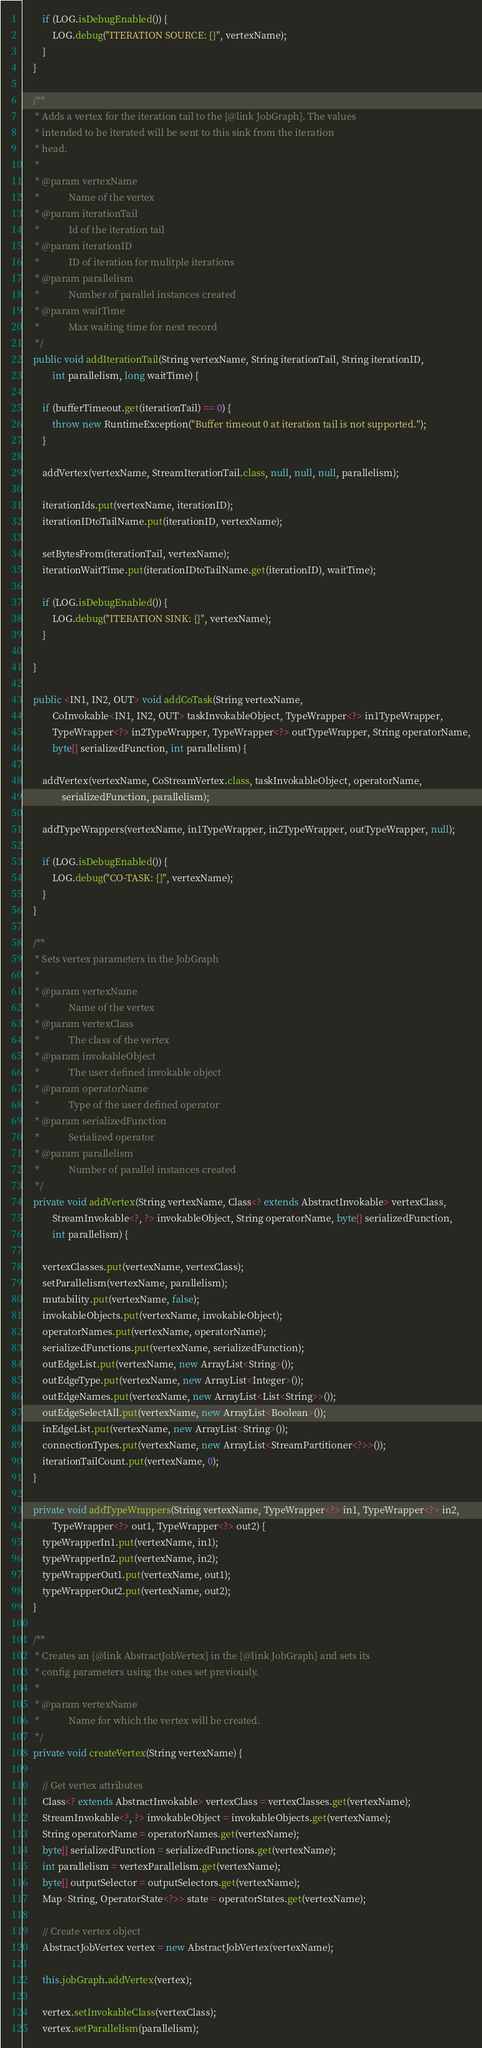<code> <loc_0><loc_0><loc_500><loc_500><_Java_>		if (LOG.isDebugEnabled()) {
			LOG.debug("ITERATION SOURCE: {}", vertexName);
		}
	}

	/**
	 * Adds a vertex for the iteration tail to the {@link JobGraph}. The values
	 * intended to be iterated will be sent to this sink from the iteration
	 * head.
	 * 
	 * @param vertexName
	 *            Name of the vertex
	 * @param iterationTail
	 *            Id of the iteration tail
	 * @param iterationID
	 *            ID of iteration for mulitple iterations
	 * @param parallelism
	 *            Number of parallel instances created
	 * @param waitTime
	 *            Max waiting time for next record
	 */
	public void addIterationTail(String vertexName, String iterationTail, String iterationID,
			int parallelism, long waitTime) {
		
		if (bufferTimeout.get(iterationTail) == 0) {
			throw new RuntimeException("Buffer timeout 0 at iteration tail is not supported.");
		}

		addVertex(vertexName, StreamIterationTail.class, null, null, null, parallelism);

		iterationIds.put(vertexName, iterationID);
		iterationIDtoTailName.put(iterationID, vertexName);

		setBytesFrom(iterationTail, vertexName);
		iterationWaitTime.put(iterationIDtoTailName.get(iterationID), waitTime);

		if (LOG.isDebugEnabled()) {
			LOG.debug("ITERATION SINK: {}", vertexName);
		}

	}

	public <IN1, IN2, OUT> void addCoTask(String vertexName,
			CoInvokable<IN1, IN2, OUT> taskInvokableObject, TypeWrapper<?> in1TypeWrapper,
			TypeWrapper<?> in2TypeWrapper, TypeWrapper<?> outTypeWrapper, String operatorName,
			byte[] serializedFunction, int parallelism) {

		addVertex(vertexName, CoStreamVertex.class, taskInvokableObject, operatorName,
				serializedFunction, parallelism);

		addTypeWrappers(vertexName, in1TypeWrapper, in2TypeWrapper, outTypeWrapper, null);

		if (LOG.isDebugEnabled()) {
			LOG.debug("CO-TASK: {}", vertexName);
		}
	}

	/**
	 * Sets vertex parameters in the JobGraph
	 * 
	 * @param vertexName
	 *            Name of the vertex
	 * @param vertexClass
	 *            The class of the vertex
	 * @param invokableObject
	 *            The user defined invokable object
	 * @param operatorName
	 *            Type of the user defined operator
	 * @param serializedFunction
	 *            Serialized operator
	 * @param parallelism
	 *            Number of parallel instances created
	 */
	private void addVertex(String vertexName, Class<? extends AbstractInvokable> vertexClass,
			StreamInvokable<?, ?> invokableObject, String operatorName, byte[] serializedFunction,
			int parallelism) {

		vertexClasses.put(vertexName, vertexClass);
		setParallelism(vertexName, parallelism);
		mutability.put(vertexName, false);
		invokableObjects.put(vertexName, invokableObject);
		operatorNames.put(vertexName, operatorName);
		serializedFunctions.put(vertexName, serializedFunction);
		outEdgeList.put(vertexName, new ArrayList<String>());
		outEdgeType.put(vertexName, new ArrayList<Integer>());
		outEdgeNames.put(vertexName, new ArrayList<List<String>>());
		outEdgeSelectAll.put(vertexName, new ArrayList<Boolean>());
		inEdgeList.put(vertexName, new ArrayList<String>());
		connectionTypes.put(vertexName, new ArrayList<StreamPartitioner<?>>());
		iterationTailCount.put(vertexName, 0);
	}

	private void addTypeWrappers(String vertexName, TypeWrapper<?> in1, TypeWrapper<?> in2,
			TypeWrapper<?> out1, TypeWrapper<?> out2) {
		typeWrapperIn1.put(vertexName, in1);
		typeWrapperIn2.put(vertexName, in2);
		typeWrapperOut1.put(vertexName, out1);
		typeWrapperOut2.put(vertexName, out2);
	}

	/**
	 * Creates an {@link AbstractJobVertex} in the {@link JobGraph} and sets its
	 * config parameters using the ones set previously.
	 * 
	 * @param vertexName
	 *            Name for which the vertex will be created.
	 */
	private void createVertex(String vertexName) {

		// Get vertex attributes
		Class<? extends AbstractInvokable> vertexClass = vertexClasses.get(vertexName);
		StreamInvokable<?, ?> invokableObject = invokableObjects.get(vertexName);
		String operatorName = operatorNames.get(vertexName);
		byte[] serializedFunction = serializedFunctions.get(vertexName);
		int parallelism = vertexParallelism.get(vertexName);
		byte[] outputSelector = outputSelectors.get(vertexName);
		Map<String, OperatorState<?>> state = operatorStates.get(vertexName);

		// Create vertex object
		AbstractJobVertex vertex = new AbstractJobVertex(vertexName);

		this.jobGraph.addVertex(vertex);

		vertex.setInvokableClass(vertexClass);
		vertex.setParallelism(parallelism);</code> 